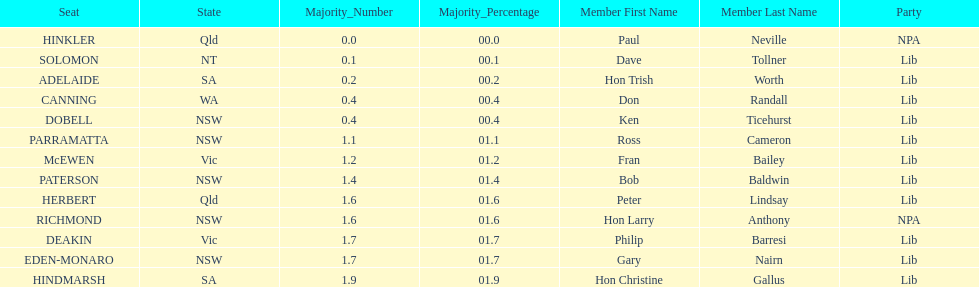How many states were represented in the seats? 6. 